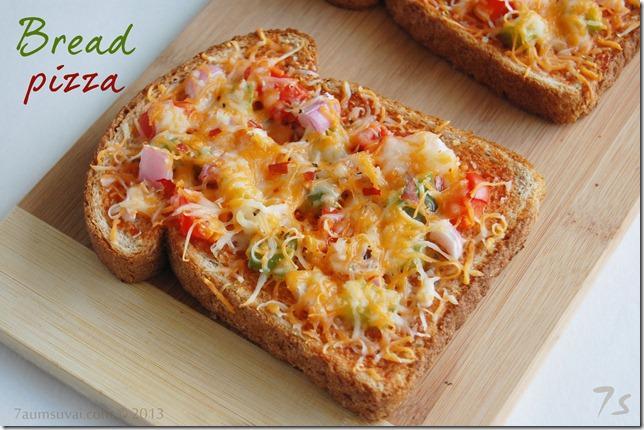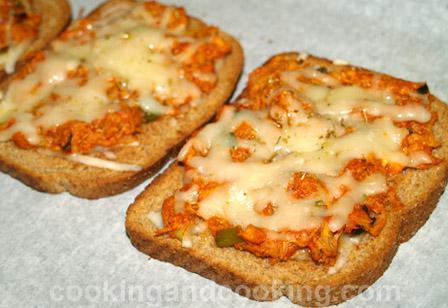The first image is the image on the left, the second image is the image on the right. Assess this claim about the two images: "All pizzas are made on pieces of bread". Correct or not? Answer yes or no. Yes. The first image is the image on the left, the second image is the image on the right. For the images displayed, is the sentence "The left image shows a round pizza cut into slices on a wooden board, and the right image shows rectangles of pizza." factually correct? Answer yes or no. No. 